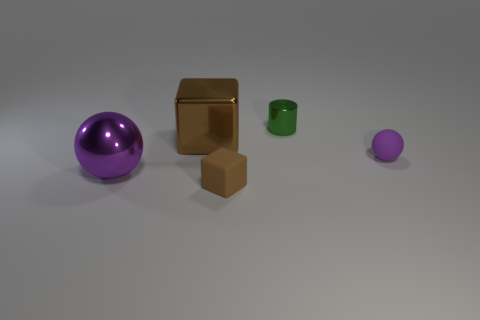There is a big purple shiny object; does it have the same shape as the rubber thing on the right side of the tiny brown object?
Give a very brief answer. Yes. What is the color of the large metallic object that is in front of the shiny block?
Your answer should be very brief. Purple. There is a ball that is to the right of the big thing on the right side of the big metallic sphere; what is its size?
Give a very brief answer. Small. Does the brown rubber object left of the tiny purple rubber object have the same shape as the large brown shiny thing?
Offer a terse response. Yes. There is another brown object that is the same shape as the brown rubber object; what material is it?
Your response must be concise. Metal. What number of objects are metallic objects in front of the large metal cube or brown cubes that are left of the rubber block?
Keep it short and to the point. 2. There is a metallic cube; does it have the same color as the cube that is on the right side of the brown metal cube?
Your answer should be very brief. Yes. There is a purple object that is made of the same material as the small cylinder; what shape is it?
Your answer should be compact. Sphere. What number of big red rubber cubes are there?
Provide a short and direct response. 0. What number of things are either small things left of the small metal cylinder or big metal balls?
Keep it short and to the point. 2. 